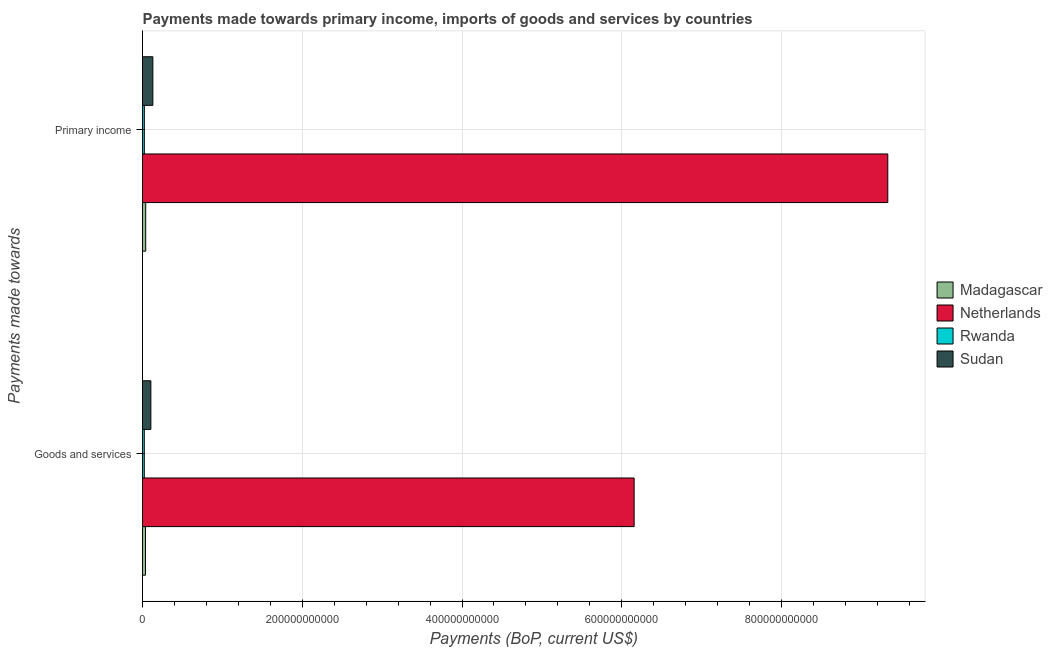How many different coloured bars are there?
Provide a short and direct response. 4. Are the number of bars per tick equal to the number of legend labels?
Your response must be concise. Yes. Are the number of bars on each tick of the Y-axis equal?
Ensure brevity in your answer.  Yes. What is the label of the 1st group of bars from the top?
Your answer should be very brief. Primary income. What is the payments made towards primary income in Rwanda?
Your response must be concise. 2.29e+09. Across all countries, what is the maximum payments made towards primary income?
Your answer should be compact. 9.33e+11. Across all countries, what is the minimum payments made towards goods and services?
Your response must be concise. 2.22e+09. In which country was the payments made towards primary income minimum?
Keep it short and to the point. Rwanda. What is the total payments made towards primary income in the graph?
Your response must be concise. 9.52e+11. What is the difference between the payments made towards primary income in Sudan and that in Madagascar?
Keep it short and to the point. 8.96e+09. What is the difference between the payments made towards goods and services in Rwanda and the payments made towards primary income in Netherlands?
Provide a succinct answer. -9.31e+11. What is the average payments made towards primary income per country?
Make the answer very short. 2.38e+11. What is the difference between the payments made towards primary income and payments made towards goods and services in Netherlands?
Provide a short and direct response. 3.18e+11. What is the ratio of the payments made towards primary income in Rwanda to that in Netherlands?
Give a very brief answer. 0. Is the payments made towards goods and services in Madagascar less than that in Netherlands?
Your response must be concise. Yes. What does the 2nd bar from the top in Goods and services represents?
Provide a short and direct response. Rwanda. What does the 1st bar from the bottom in Goods and services represents?
Provide a succinct answer. Madagascar. How many bars are there?
Make the answer very short. 8. Are all the bars in the graph horizontal?
Your response must be concise. Yes. What is the difference between two consecutive major ticks on the X-axis?
Keep it short and to the point. 2.00e+11. Are the values on the major ticks of X-axis written in scientific E-notation?
Make the answer very short. No. Where does the legend appear in the graph?
Offer a terse response. Center right. How are the legend labels stacked?
Make the answer very short. Vertical. What is the title of the graph?
Provide a succinct answer. Payments made towards primary income, imports of goods and services by countries. Does "Indonesia" appear as one of the legend labels in the graph?
Provide a succinct answer. No. What is the label or title of the X-axis?
Give a very brief answer. Payments (BoP, current US$). What is the label or title of the Y-axis?
Ensure brevity in your answer.  Payments made towards. What is the Payments (BoP, current US$) in Madagascar in Goods and services?
Offer a terse response. 3.78e+09. What is the Payments (BoP, current US$) of Netherlands in Goods and services?
Keep it short and to the point. 6.15e+11. What is the Payments (BoP, current US$) in Rwanda in Goods and services?
Provide a short and direct response. 2.22e+09. What is the Payments (BoP, current US$) in Sudan in Goods and services?
Provide a short and direct response. 1.05e+1. What is the Payments (BoP, current US$) of Madagascar in Primary income?
Your answer should be very brief. 4.02e+09. What is the Payments (BoP, current US$) in Netherlands in Primary income?
Offer a very short reply. 9.33e+11. What is the Payments (BoP, current US$) of Rwanda in Primary income?
Ensure brevity in your answer.  2.29e+09. What is the Payments (BoP, current US$) in Sudan in Primary income?
Your answer should be compact. 1.30e+1. Across all Payments made towards, what is the maximum Payments (BoP, current US$) of Madagascar?
Offer a terse response. 4.02e+09. Across all Payments made towards, what is the maximum Payments (BoP, current US$) in Netherlands?
Provide a short and direct response. 9.33e+11. Across all Payments made towards, what is the maximum Payments (BoP, current US$) in Rwanda?
Ensure brevity in your answer.  2.29e+09. Across all Payments made towards, what is the maximum Payments (BoP, current US$) in Sudan?
Your answer should be very brief. 1.30e+1. Across all Payments made towards, what is the minimum Payments (BoP, current US$) of Madagascar?
Your response must be concise. 3.78e+09. Across all Payments made towards, what is the minimum Payments (BoP, current US$) in Netherlands?
Your answer should be compact. 6.15e+11. Across all Payments made towards, what is the minimum Payments (BoP, current US$) in Rwanda?
Your answer should be compact. 2.22e+09. Across all Payments made towards, what is the minimum Payments (BoP, current US$) in Sudan?
Provide a succinct answer. 1.05e+1. What is the total Payments (BoP, current US$) in Madagascar in the graph?
Your response must be concise. 7.79e+09. What is the total Payments (BoP, current US$) in Netherlands in the graph?
Provide a short and direct response. 1.55e+12. What is the total Payments (BoP, current US$) of Rwanda in the graph?
Give a very brief answer. 4.51e+09. What is the total Payments (BoP, current US$) in Sudan in the graph?
Your response must be concise. 2.34e+1. What is the difference between the Payments (BoP, current US$) in Madagascar in Goods and services and that in Primary income?
Make the answer very short. -2.41e+08. What is the difference between the Payments (BoP, current US$) in Netherlands in Goods and services and that in Primary income?
Provide a succinct answer. -3.18e+11. What is the difference between the Payments (BoP, current US$) in Rwanda in Goods and services and that in Primary income?
Provide a short and direct response. -7.19e+07. What is the difference between the Payments (BoP, current US$) in Sudan in Goods and services and that in Primary income?
Your answer should be compact. -2.51e+09. What is the difference between the Payments (BoP, current US$) in Madagascar in Goods and services and the Payments (BoP, current US$) in Netherlands in Primary income?
Offer a very short reply. -9.29e+11. What is the difference between the Payments (BoP, current US$) in Madagascar in Goods and services and the Payments (BoP, current US$) in Rwanda in Primary income?
Your answer should be compact. 1.48e+09. What is the difference between the Payments (BoP, current US$) in Madagascar in Goods and services and the Payments (BoP, current US$) in Sudan in Primary income?
Provide a short and direct response. -9.20e+09. What is the difference between the Payments (BoP, current US$) of Netherlands in Goods and services and the Payments (BoP, current US$) of Rwanda in Primary income?
Your answer should be compact. 6.13e+11. What is the difference between the Payments (BoP, current US$) in Netherlands in Goods and services and the Payments (BoP, current US$) in Sudan in Primary income?
Offer a very short reply. 6.03e+11. What is the difference between the Payments (BoP, current US$) in Rwanda in Goods and services and the Payments (BoP, current US$) in Sudan in Primary income?
Provide a short and direct response. -1.08e+1. What is the average Payments (BoP, current US$) of Madagascar per Payments made towards?
Offer a very short reply. 3.90e+09. What is the average Payments (BoP, current US$) in Netherlands per Payments made towards?
Your response must be concise. 7.74e+11. What is the average Payments (BoP, current US$) in Rwanda per Payments made towards?
Give a very brief answer. 2.25e+09. What is the average Payments (BoP, current US$) in Sudan per Payments made towards?
Ensure brevity in your answer.  1.17e+1. What is the difference between the Payments (BoP, current US$) of Madagascar and Payments (BoP, current US$) of Netherlands in Goods and services?
Provide a short and direct response. -6.12e+11. What is the difference between the Payments (BoP, current US$) of Madagascar and Payments (BoP, current US$) of Rwanda in Goods and services?
Ensure brevity in your answer.  1.56e+09. What is the difference between the Payments (BoP, current US$) of Madagascar and Payments (BoP, current US$) of Sudan in Goods and services?
Give a very brief answer. -6.69e+09. What is the difference between the Payments (BoP, current US$) of Netherlands and Payments (BoP, current US$) of Rwanda in Goods and services?
Offer a very short reply. 6.13e+11. What is the difference between the Payments (BoP, current US$) in Netherlands and Payments (BoP, current US$) in Sudan in Goods and services?
Your response must be concise. 6.05e+11. What is the difference between the Payments (BoP, current US$) in Rwanda and Payments (BoP, current US$) in Sudan in Goods and services?
Keep it short and to the point. -8.25e+09. What is the difference between the Payments (BoP, current US$) in Madagascar and Payments (BoP, current US$) in Netherlands in Primary income?
Keep it short and to the point. -9.29e+11. What is the difference between the Payments (BoP, current US$) of Madagascar and Payments (BoP, current US$) of Rwanda in Primary income?
Offer a terse response. 1.72e+09. What is the difference between the Payments (BoP, current US$) of Madagascar and Payments (BoP, current US$) of Sudan in Primary income?
Your response must be concise. -8.96e+09. What is the difference between the Payments (BoP, current US$) in Netherlands and Payments (BoP, current US$) in Rwanda in Primary income?
Your answer should be very brief. 9.31e+11. What is the difference between the Payments (BoP, current US$) in Netherlands and Payments (BoP, current US$) in Sudan in Primary income?
Your response must be concise. 9.20e+11. What is the difference between the Payments (BoP, current US$) of Rwanda and Payments (BoP, current US$) of Sudan in Primary income?
Provide a succinct answer. -1.07e+1. What is the ratio of the Payments (BoP, current US$) in Madagascar in Goods and services to that in Primary income?
Offer a very short reply. 0.94. What is the ratio of the Payments (BoP, current US$) of Netherlands in Goods and services to that in Primary income?
Offer a terse response. 0.66. What is the ratio of the Payments (BoP, current US$) of Rwanda in Goods and services to that in Primary income?
Offer a terse response. 0.97. What is the ratio of the Payments (BoP, current US$) of Sudan in Goods and services to that in Primary income?
Keep it short and to the point. 0.81. What is the difference between the highest and the second highest Payments (BoP, current US$) in Madagascar?
Your answer should be very brief. 2.41e+08. What is the difference between the highest and the second highest Payments (BoP, current US$) of Netherlands?
Offer a very short reply. 3.18e+11. What is the difference between the highest and the second highest Payments (BoP, current US$) in Rwanda?
Offer a terse response. 7.19e+07. What is the difference between the highest and the second highest Payments (BoP, current US$) of Sudan?
Provide a succinct answer. 2.51e+09. What is the difference between the highest and the lowest Payments (BoP, current US$) of Madagascar?
Your answer should be very brief. 2.41e+08. What is the difference between the highest and the lowest Payments (BoP, current US$) of Netherlands?
Your response must be concise. 3.18e+11. What is the difference between the highest and the lowest Payments (BoP, current US$) in Rwanda?
Provide a succinct answer. 7.19e+07. What is the difference between the highest and the lowest Payments (BoP, current US$) in Sudan?
Offer a very short reply. 2.51e+09. 